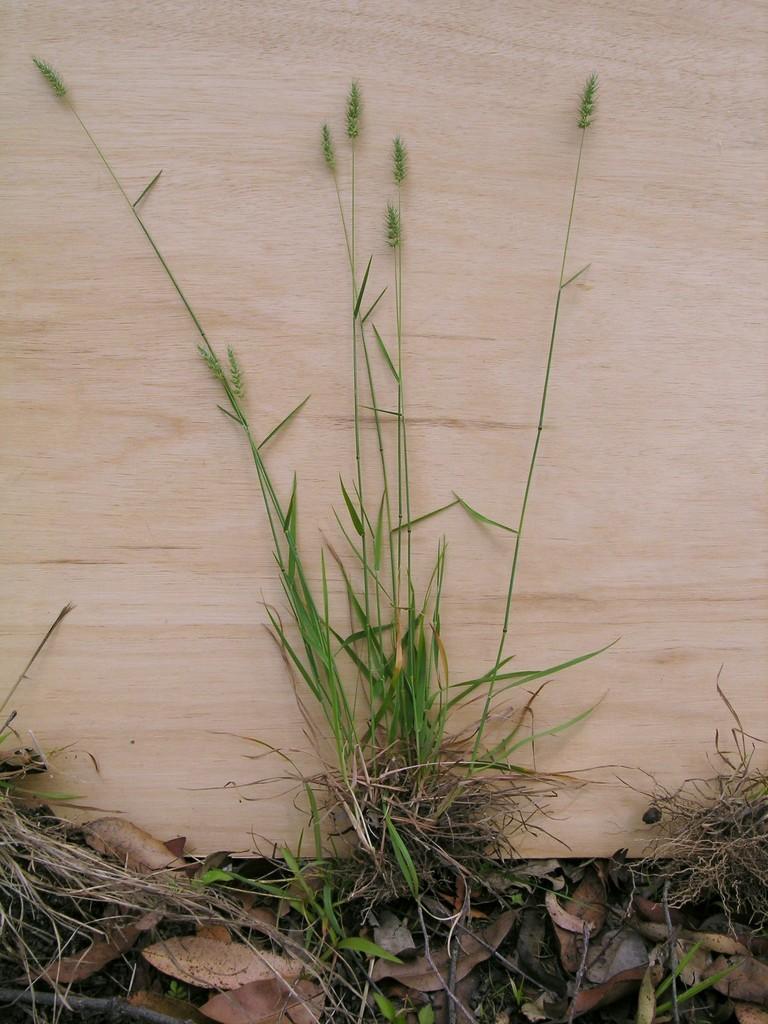In one or two sentences, can you explain what this image depicts? In this picture I can see some plants side of the wooden thing. 